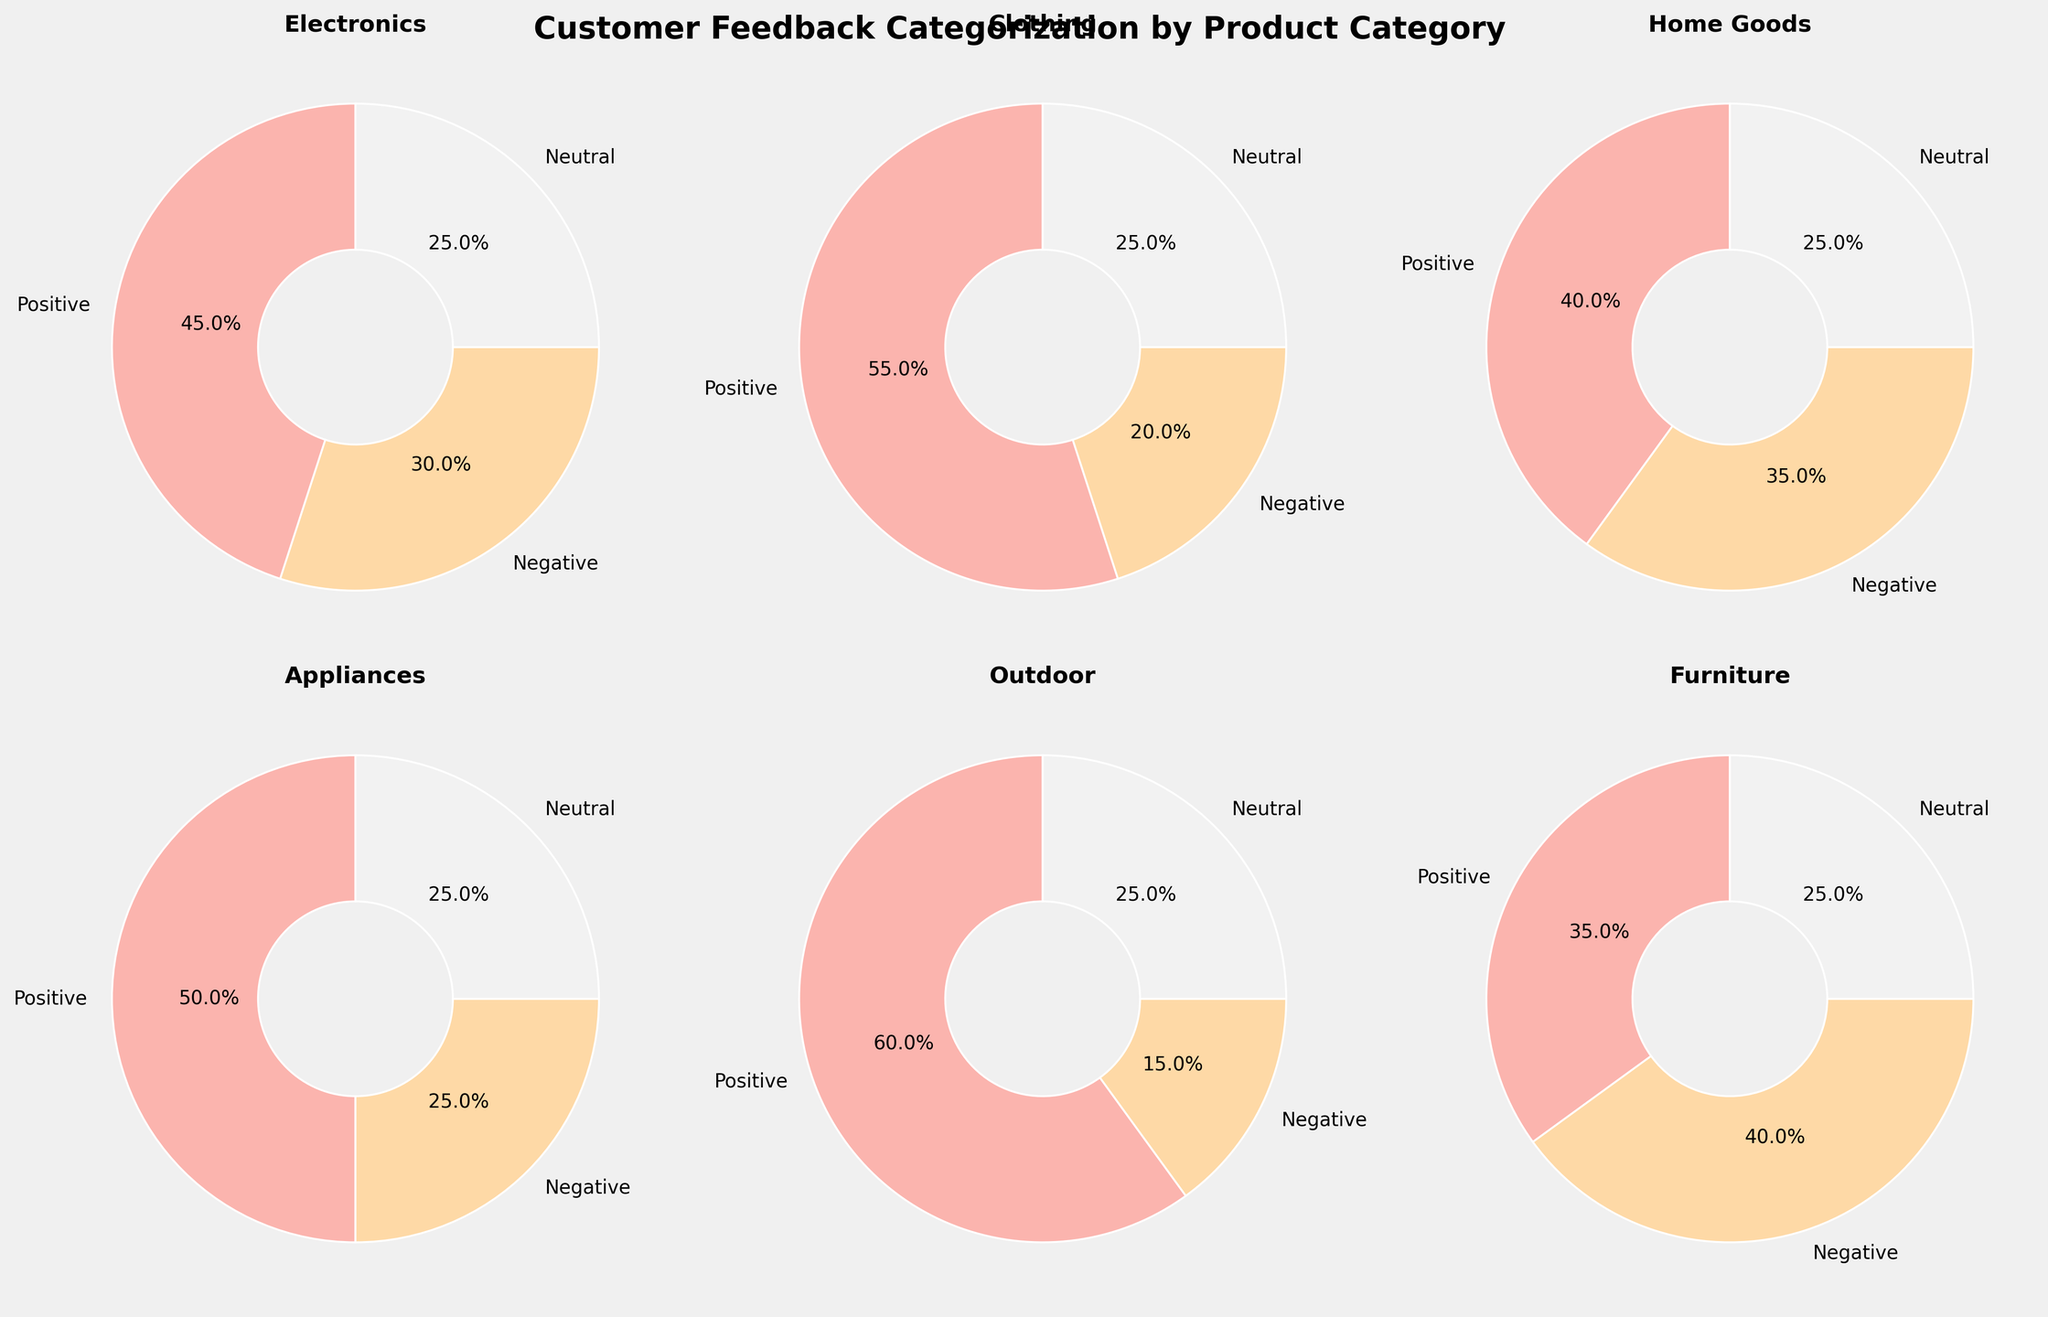Which category has the highest percentage of positive feedback? By examining each pie chart, the "Outdoor" category has the highest percentage of positive feedback at 60%.
Answer: Outdoor What is the combined percentage of negative feedback for Electronics and Home Goods? Electronics has 30% negative feedback and Home Goods has 35%. Combined, 30% + 35% = 65%.
Answer: 65% Which category has the smallest proportion of neutral feedback? All categories have an equal proportion of neutral feedback at 25%.
Answer: All categories Is there any category where negative feedback is higher than positive feedback? By observing the pie charts, in the "Furniture" category, negative feedback (40%) is higher than positive feedback (35%).
Answer: Furniture Compare the percentages of positive and negative feedback for the Clothing category. Which is higher and by how much? The positive feedback for Clothing is 55%, and the negative feedback is 20%. The difference is 55% - 20% = 35%. Positive feedback is higher by 35%.
Answer: Positive by 35% What is the average percentage of positive feedback across all categories? Add the percentages of positive feedback for each category: (45 + 55 + 40 + 50 + 60 + 35) = 285%. There are 6 categories, so the average is 285 / 6 = 47.5%.
Answer: 47.5% Which two categories have the closest percentages of neutral feedback? All categories have equal neutral feedback at 25%. Therefore, all categories are equally closest for neutral feedback.
Answer: All categories How does the percentage of negative feedback in Appliances compare to that in Home Goods? The appliances category has 25% negative feedback, while home goods has 35%. Home Goods has a higher percentage (35% vs. 25%).
Answer: Home Goods higher Rank the categories from highest to lowest based on positive feedback percentages. The positive feedback percentages are: Outdoor (60%), Clothing (55%), Appliances (50%), Electronics (45%), Home Goods (40%), Furniture (35%). The ranking is Outdoor > Clothing > Appliances > Electronics > Home Goods > Furniture.
Answer: Outdoor, Clothing, Appliances, Electronics, Home Goods, Furniture 